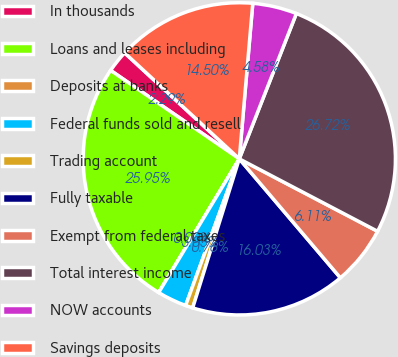Convert chart to OTSL. <chart><loc_0><loc_0><loc_500><loc_500><pie_chart><fcel>In thousands<fcel>Loans and leases including<fcel>Deposits at banks<fcel>Federal funds sold and resell<fcel>Trading account<fcel>Fully taxable<fcel>Exempt from federal taxes<fcel>Total interest income<fcel>NOW accounts<fcel>Savings deposits<nl><fcel>2.29%<fcel>25.95%<fcel>0.0%<fcel>3.05%<fcel>0.76%<fcel>16.03%<fcel>6.11%<fcel>26.72%<fcel>4.58%<fcel>14.5%<nl></chart> 